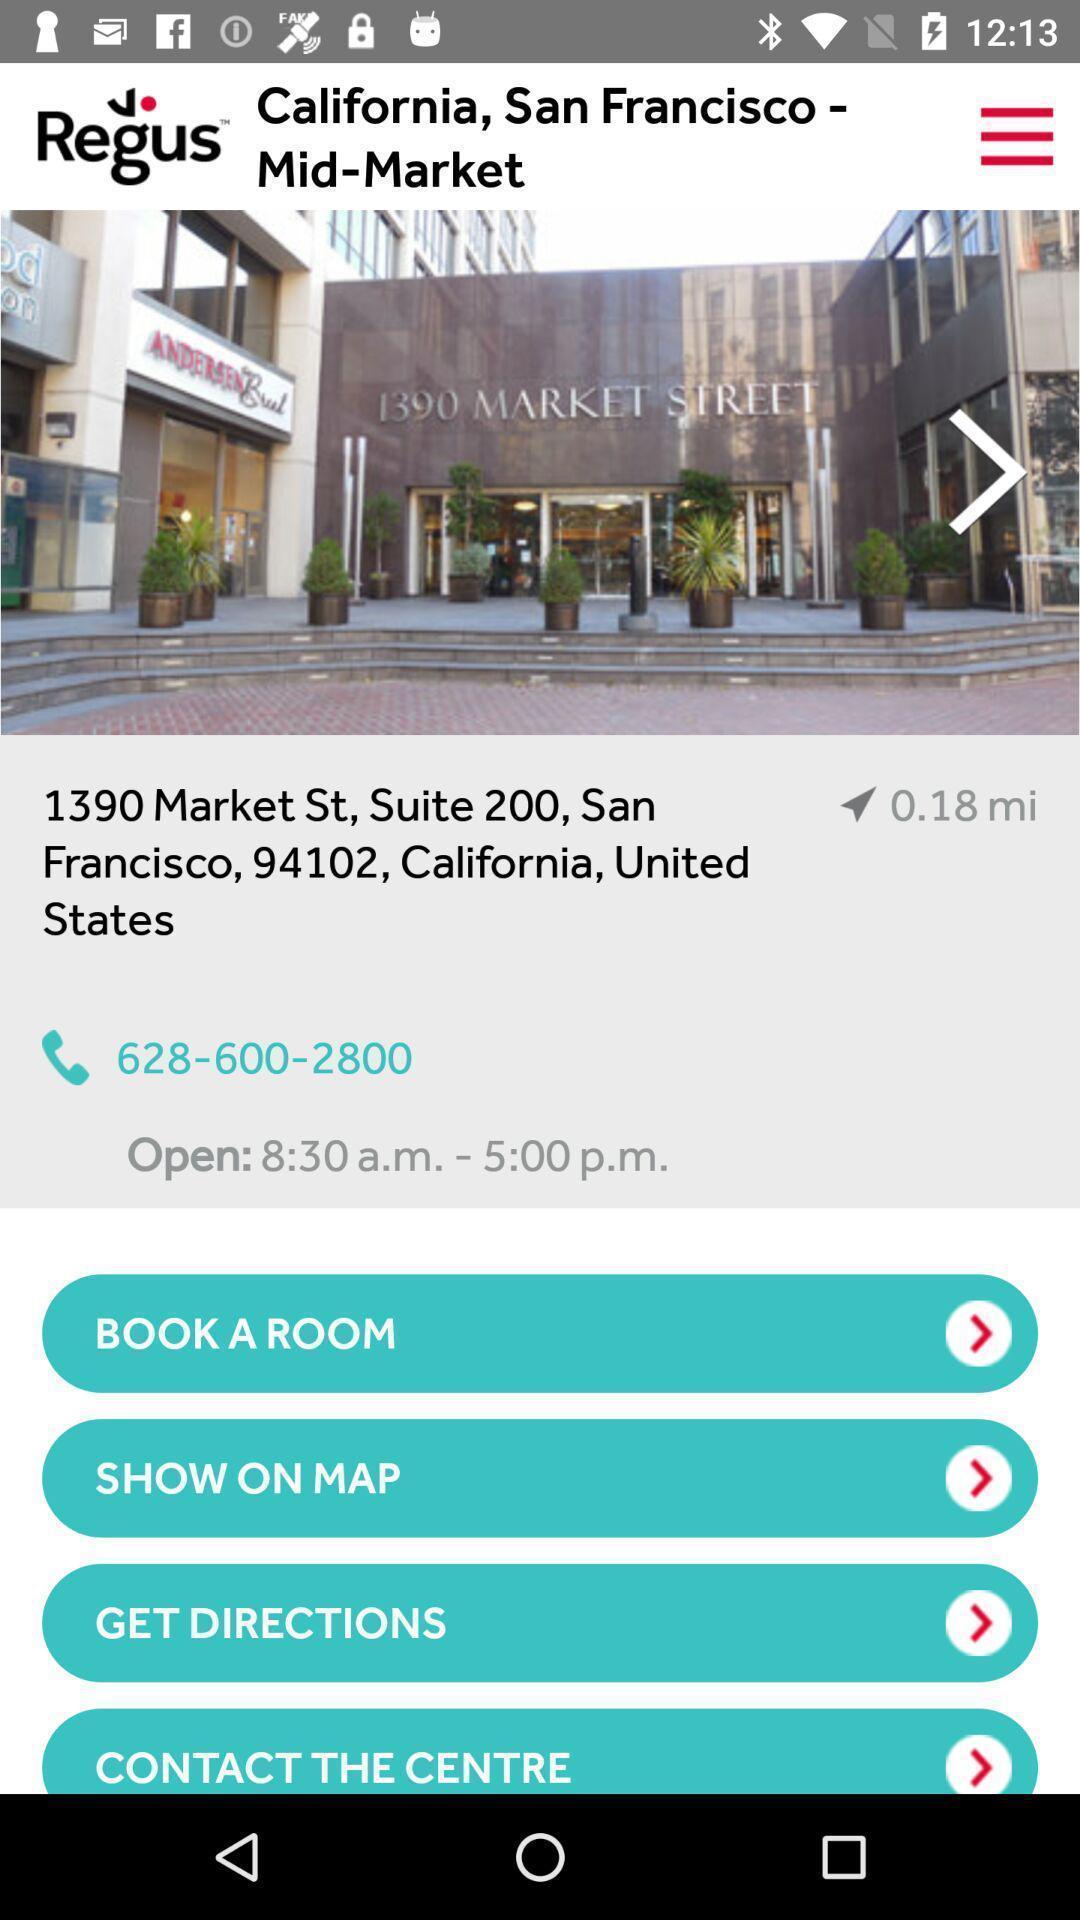Tell me about the visual elements in this screen capture. Welcome page displaying with different options of an bookings application. 